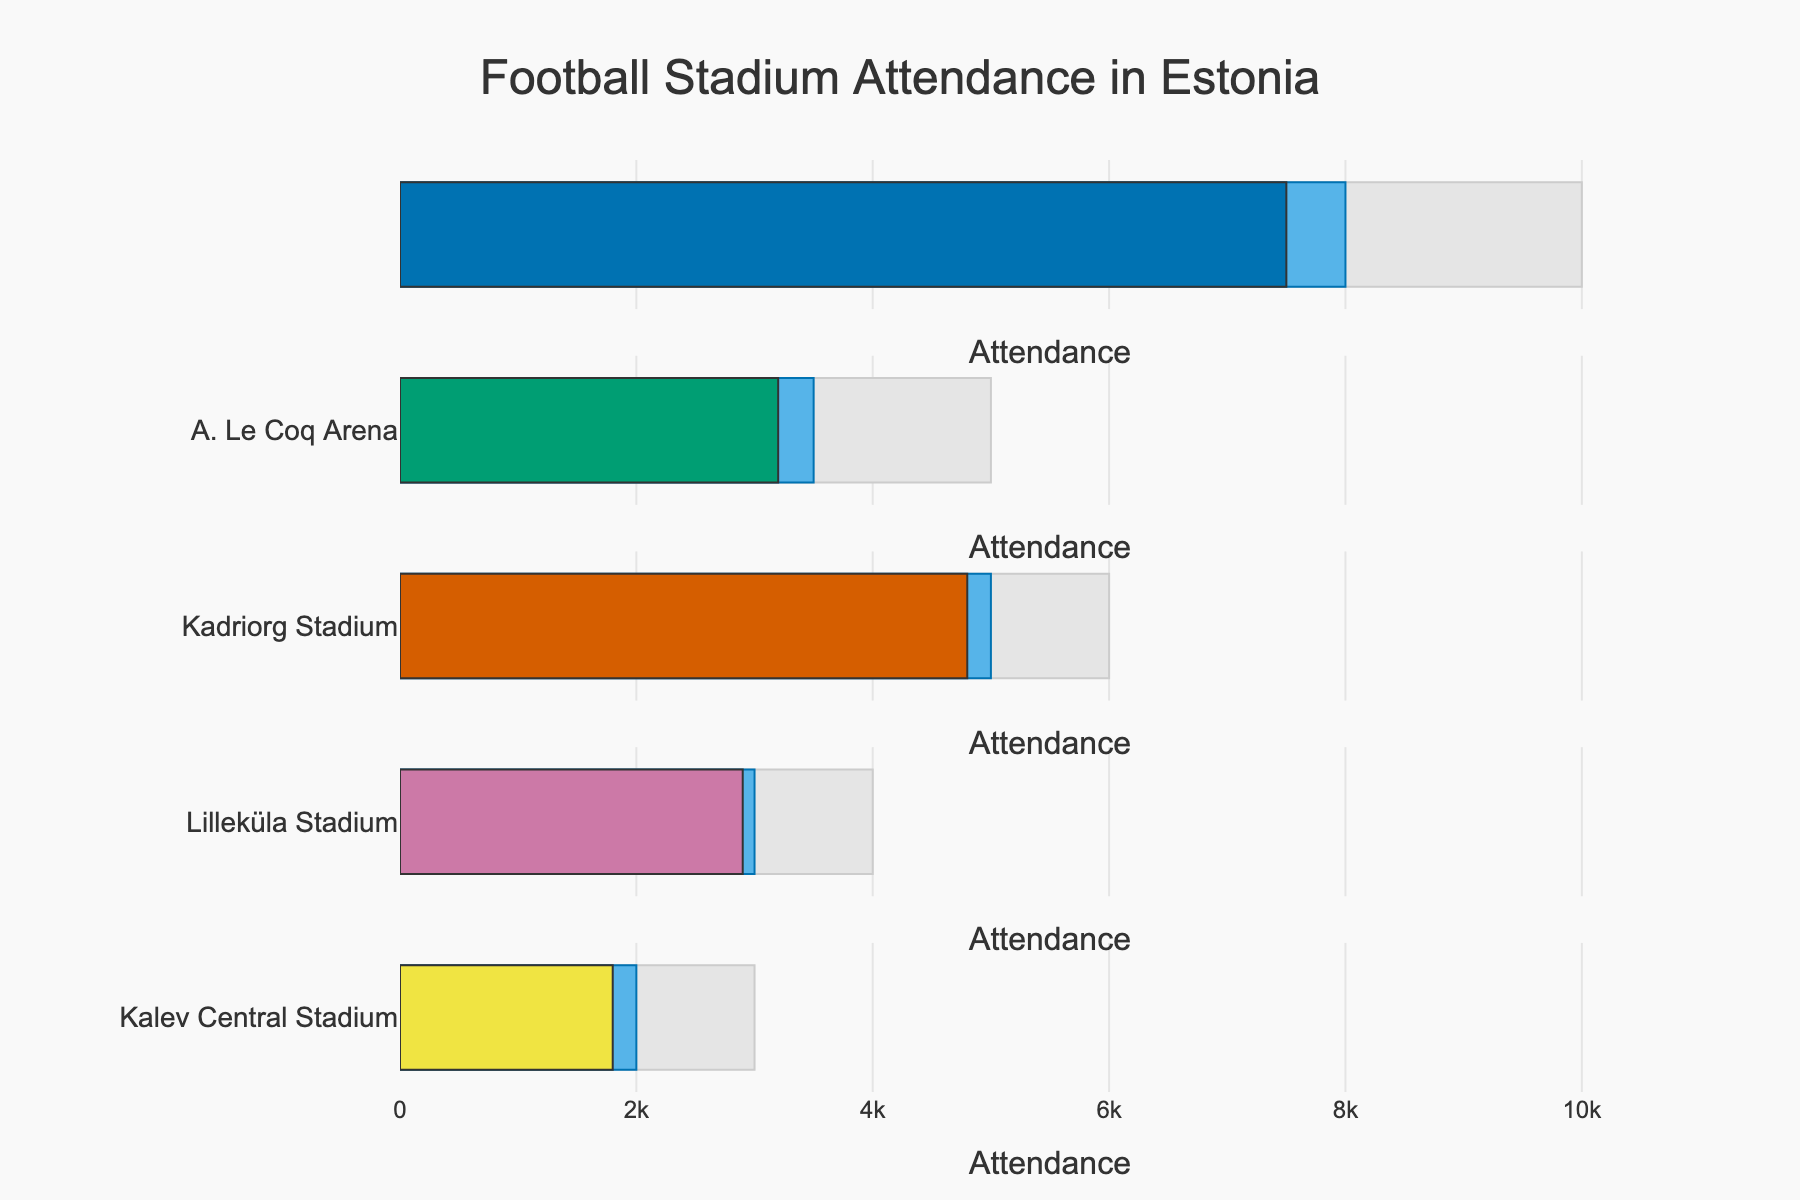What's the title of the figure? The title is typically located at the top of the figure and is used to describe what the figure represents. In this case, the title is 'Football Stadium Attendance in Estonia'.
Answer: Football Stadium Attendance in Estonia Which stadium had the highest actual attendance? To find the highest actual attendance, look for the longest "Actual" bar in the figure. The longest bar is for 'A. Le Coq Arena', which indicates the highest attendance.
Answer: A. Le Coq Arena What is the maximum capacity for Lilleküla Stadium? In the bullet chart, the "Maximum" bar represents the maximum capacity of each stadium. For Lilleküla Stadium, you should find the bar labeled "Maximum" and note that it extends to 6000.
Answer: 6000 Compare the actual and projected attendance for Pärnu Rannastaadion. Which is higher? By examining the length of the "Actual" and "Projected" bars for Pärnu Rannastaadion, you can see that the "Projected" bar is slightly longer, indicating that the projected attendance (2000) is higher than the actual attendance (1800).
Answer: Projected What's the difference between the maximum and actual attendance for Kadriorg Stadium? Find the bars for Kadriorg Stadium. To calculate the difference, subtract the value at the end of the "Actual" bar (3200) from the value at the end of the "Maximum" bar (5000). Thus, 5000 - 3200 = 1800.
Answer: 1800 Which stadium has the smallest difference between actual and maximum attendance? Calculate the difference between the maximum and actual attendance for each stadium by subtracting the "Actual" values from the "Maximum" values. The smallest difference is found for Kadriorg Stadium (5000 - 3200 = 1800).
Answer: Kadriorg Stadium How many stadiums have an actual attendance greater than 3000? Examine the "Actual" bars for all stadiums. Count the number of stadiums where the "Actual" bar value is greater than 3000, which are A. Le Coq Arena, Kadriorg Stadium, and Lilleküla Stadium. Thus, there are 3 stadiums.
Answer: 3 What is the average projected attendance across all stadiums? Add up the projected attendance values: (8000 + 3500 + 5000 + 3000 + 2000) = 21500. Then divide by the number of stadiums (5): 21500 / 5 = 4300.
Answer: 4300 